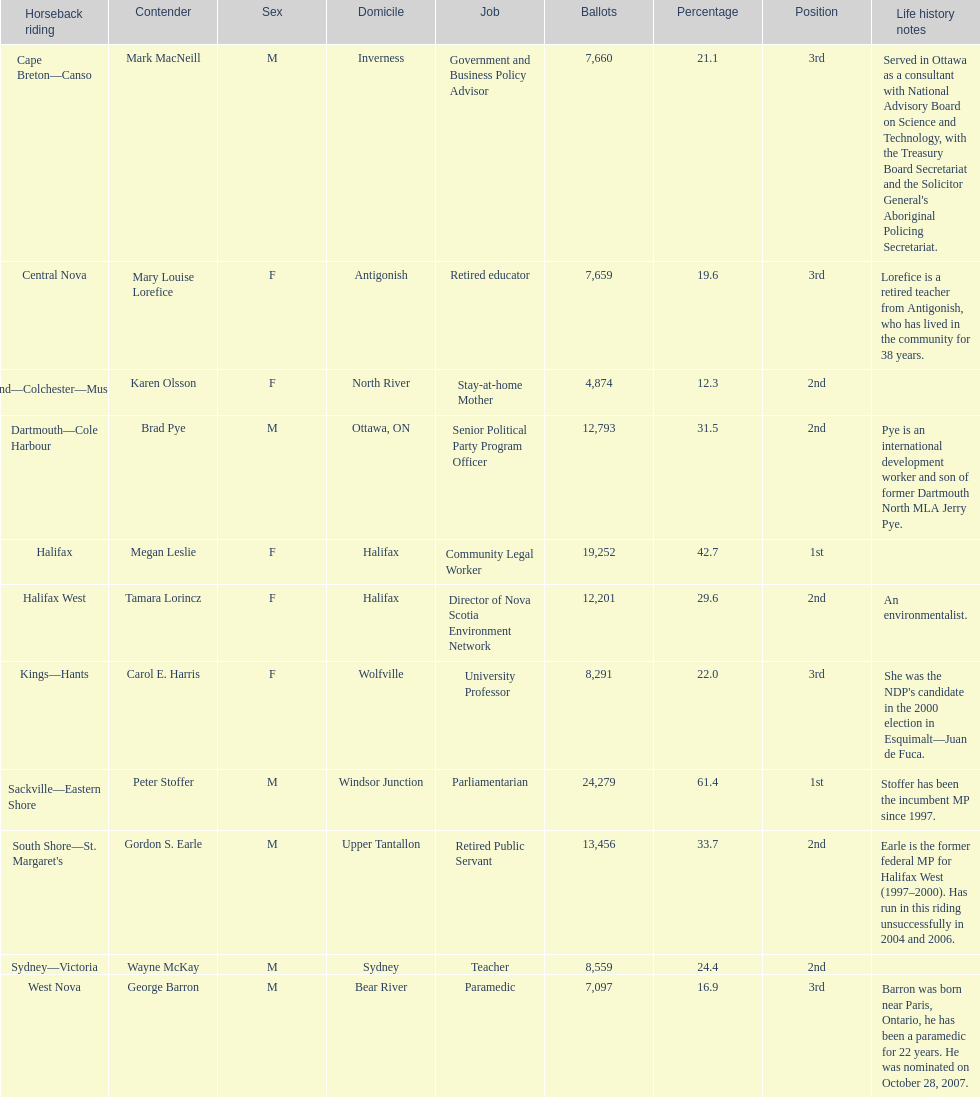How many contenders received a higher number of votes than tamara lorincz? 4. 